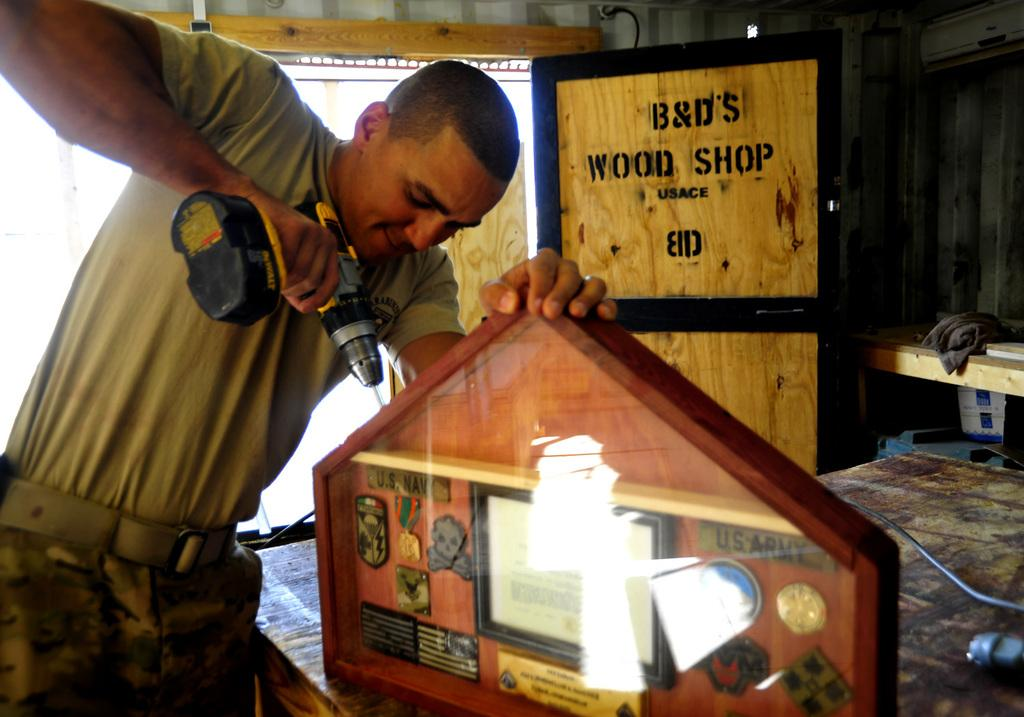<image>
Offer a succinct explanation of the picture presented. Man working on something with B&D's Wood Shop board in the back. 